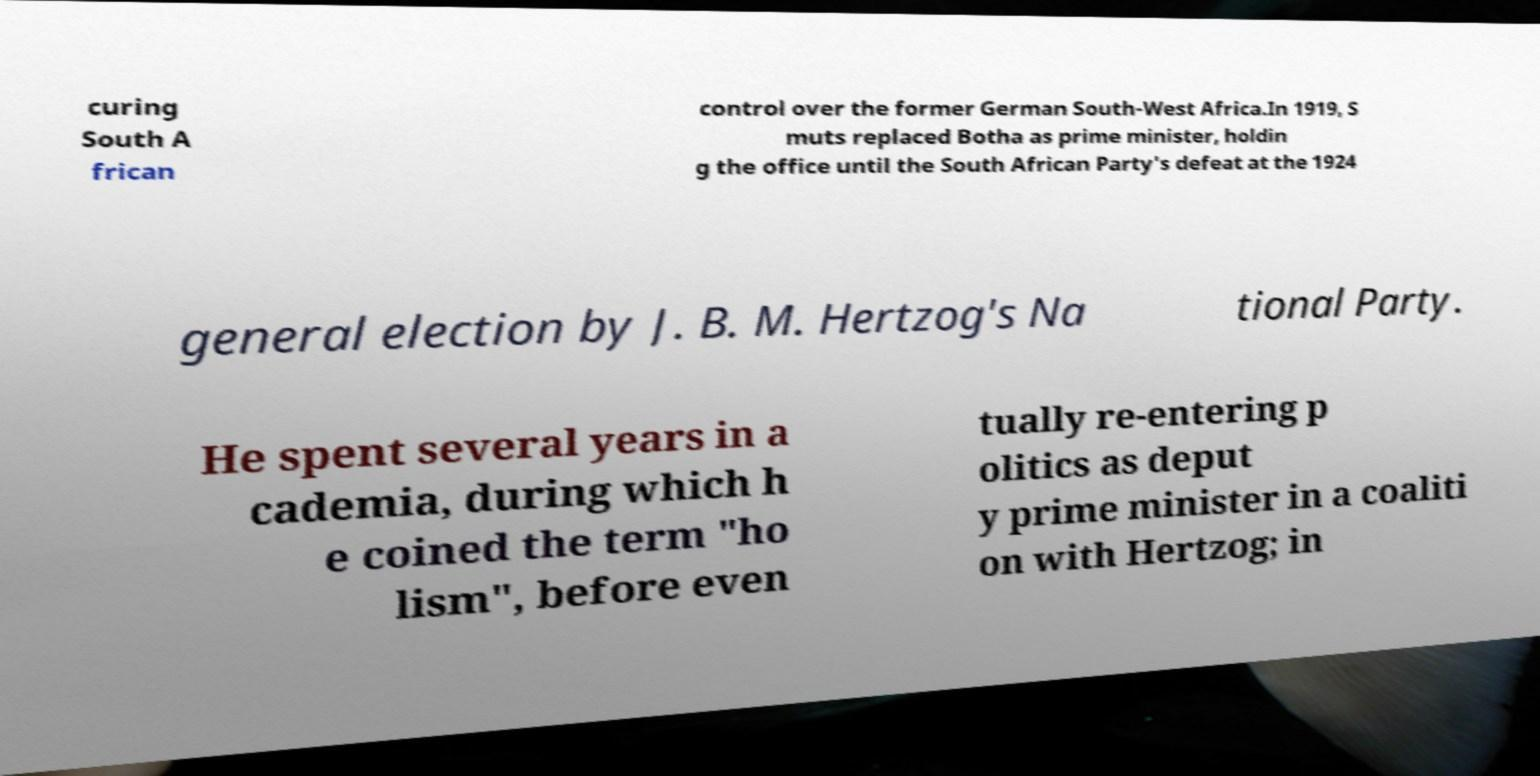Could you extract and type out the text from this image? curing South A frican control over the former German South-West Africa.In 1919, S muts replaced Botha as prime minister, holdin g the office until the South African Party's defeat at the 1924 general election by J. B. M. Hertzog's Na tional Party. He spent several years in a cademia, during which h e coined the term "ho lism", before even tually re-entering p olitics as deput y prime minister in a coaliti on with Hertzog; in 